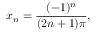<formula> <loc_0><loc_0><loc_500><loc_500>x _ { n } = { \frac { ( - 1 ) ^ { n } } { ( 2 n + 1 ) \pi } } ,</formula> 